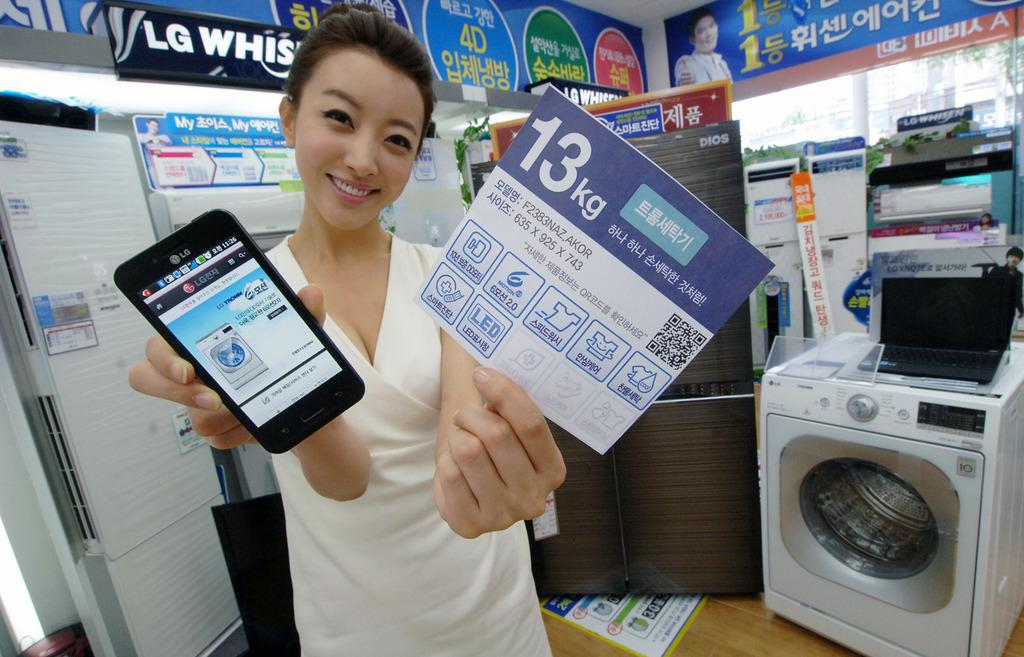<image>
Describe the image concisely. A woman standing in a store with several LG brand products and signs on the walls while holding a cell phone and paper. 